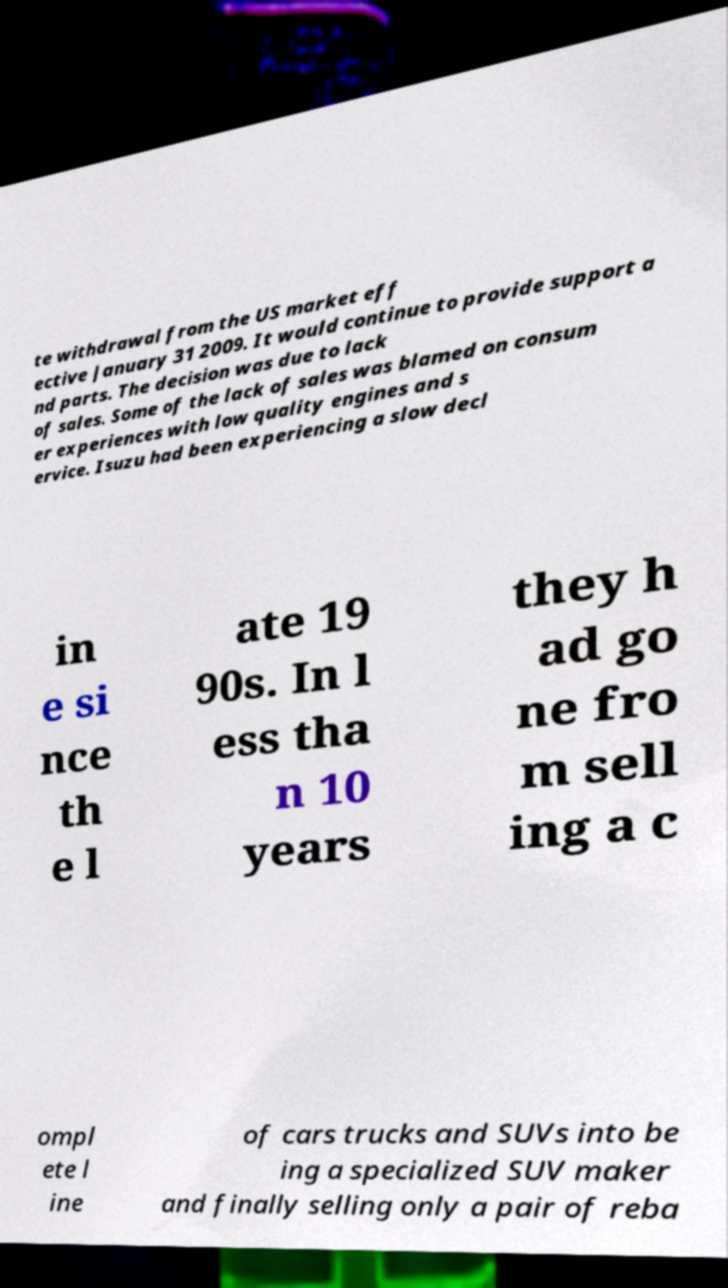I need the written content from this picture converted into text. Can you do that? te withdrawal from the US market eff ective January 31 2009. It would continue to provide support a nd parts. The decision was due to lack of sales. Some of the lack of sales was blamed on consum er experiences with low quality engines and s ervice. Isuzu had been experiencing a slow decl in e si nce th e l ate 19 90s. In l ess tha n 10 years they h ad go ne fro m sell ing a c ompl ete l ine of cars trucks and SUVs into be ing a specialized SUV maker and finally selling only a pair of reba 